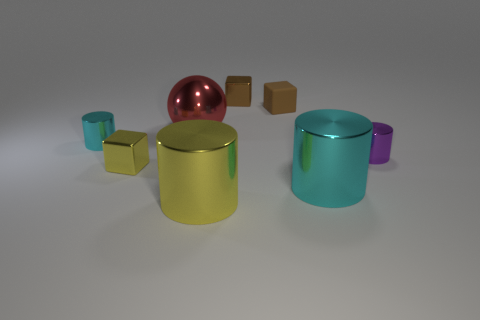What could be the possible functionality or purpose of these objects? While these objects are depicted in a generic environment that abstracts away their context, one could infer possible uses. The spherical object, owing to its size and shine, could be a decorative piece or part of a larger installation. The cylindrical items might serve as containers or stands, perhaps for storage or display purposes due to their open tops. And the small cubes could be building blocks or paperweights, depending on their actual size and weight. 